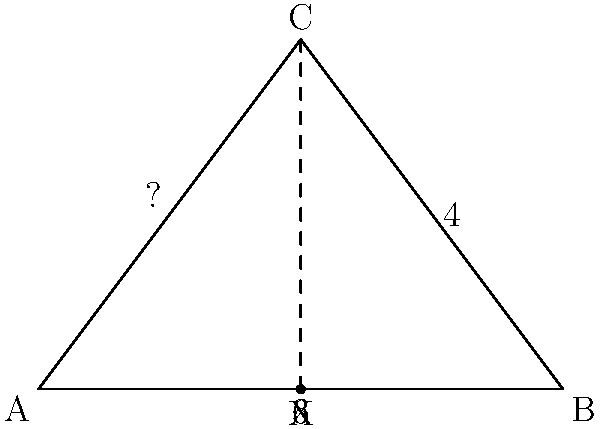In a secret government facility, a whistleblower has revealed a triangular room where classified experiments are conducted. The room's dimensions are known: the base is 6 units long, and the height from the base to the apex is 4 units. If this information is part of a larger conspiracy, what is the angle of inclination (in degrees) from the base to the slanted wall? This angle could be crucial in exposing the true nature of the experiments. Let's approach this step-by-step, keeping in mind that the government might not want us to know this information:

1) The room forms a right-angled triangle. We need to find the angle between the base and the slanted wall.

2) We can use the tangent function to find this angle. The tangent of an angle is the ratio of the opposite side to the adjacent side.

3) In this case:
   - The opposite side (height) is 4 units
   - The adjacent side (half of the base) is 3 units

4) Let's call our angle θ. Then:

   $$\tan(\theta) = \frac{\text{opposite}}{\text{adjacent}} = \frac{4}{3}$$

5) To find θ, we need to use the inverse tangent (arctan or tan^(-1)):

   $$\theta = \tan^{-1}(\frac{4}{3})$$

6) Using a calculator (which the government probably doesn't want us to have):

   $$\theta \approx 53.13010235415598^\circ$$

7) Rounding to two decimal places:

   $$\theta \approx 53.13^\circ$$

This angle could be a key to understanding the true purpose of this secret facility.
Answer: $53.13^\circ$ 